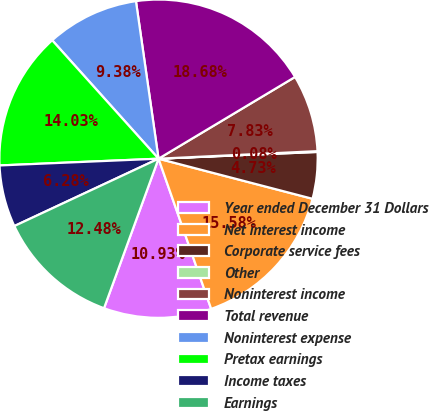<chart> <loc_0><loc_0><loc_500><loc_500><pie_chart><fcel>Year ended December 31 Dollars<fcel>Net interest income<fcel>Corporate service fees<fcel>Other<fcel>Noninterest income<fcel>Total revenue<fcel>Noninterest expense<fcel>Pretax earnings<fcel>Income taxes<fcel>Earnings<nl><fcel>10.93%<fcel>15.58%<fcel>4.73%<fcel>0.08%<fcel>7.83%<fcel>18.68%<fcel>9.38%<fcel>14.03%<fcel>6.28%<fcel>12.48%<nl></chart> 